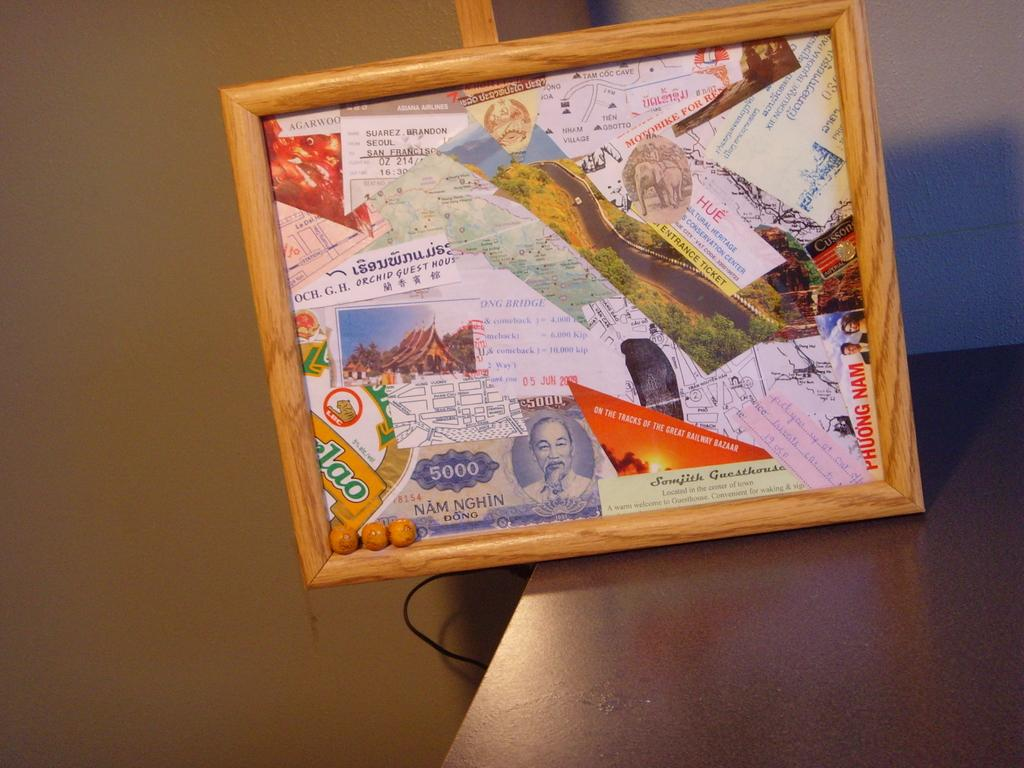What is the main object in the image? There is a board in the image. What is the board placed on? The board is on a brown surface. How would you describe the appearance of the board? The board is colorful. What can be seen in the background of the image? There is a wall visible in the background of the image. Can you see any faces on the board in the image? There are no faces visible on the board in the image. Is there a zipper on the board in the image? There is no zipper present on the board in the image. 